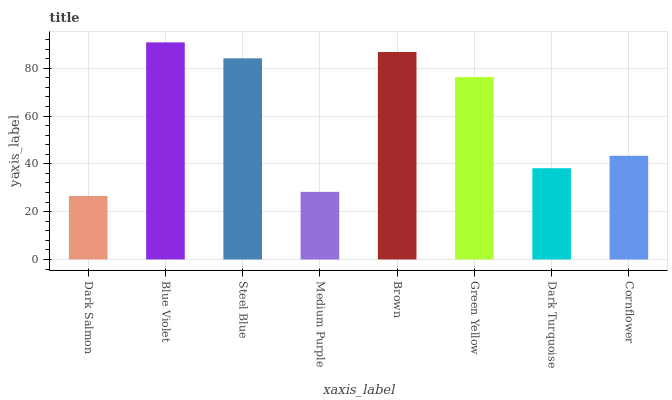Is Dark Salmon the minimum?
Answer yes or no. Yes. Is Blue Violet the maximum?
Answer yes or no. Yes. Is Steel Blue the minimum?
Answer yes or no. No. Is Steel Blue the maximum?
Answer yes or no. No. Is Blue Violet greater than Steel Blue?
Answer yes or no. Yes. Is Steel Blue less than Blue Violet?
Answer yes or no. Yes. Is Steel Blue greater than Blue Violet?
Answer yes or no. No. Is Blue Violet less than Steel Blue?
Answer yes or no. No. Is Green Yellow the high median?
Answer yes or no. Yes. Is Cornflower the low median?
Answer yes or no. Yes. Is Medium Purple the high median?
Answer yes or no. No. Is Medium Purple the low median?
Answer yes or no. No. 